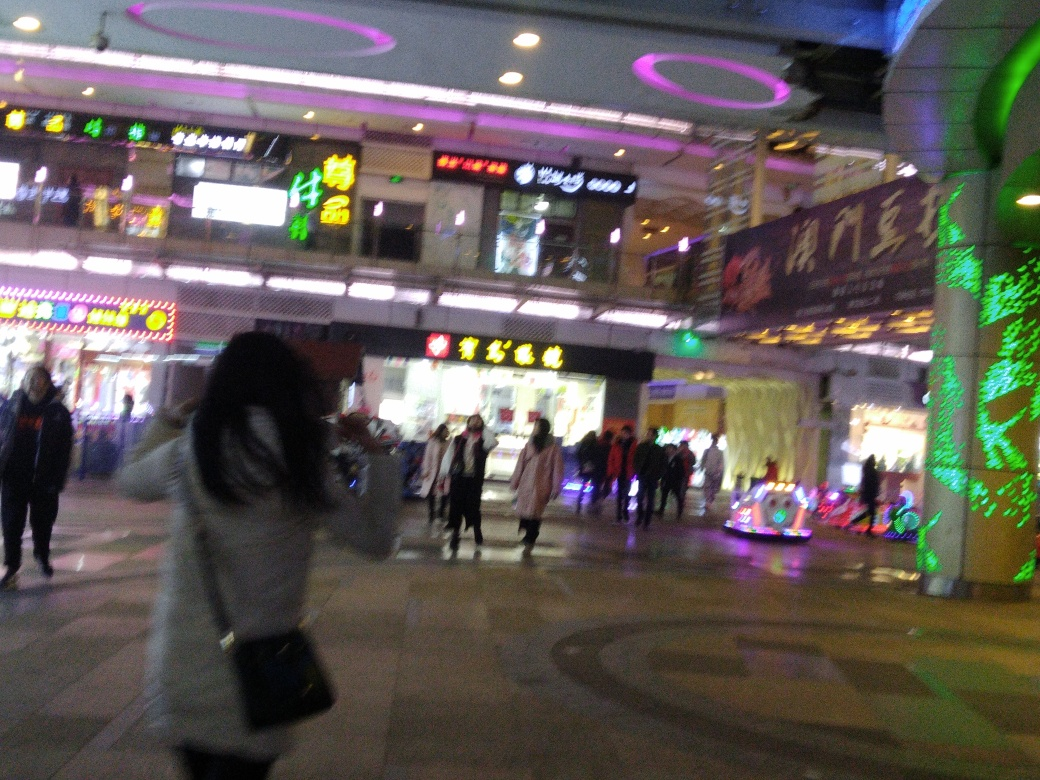Can you describe the atmosphere of the setting depicted in the image? The image exudes the vibrant energy of an evening in a bustling urban environment. Neon signs and illuminated decorations cast a colorful glow, which contrasts with the darkening sky, suggesting a lively commercial area active at night. The sense of movement, likely due to pedestrians going about their evenings, complements the dynamic feel of this urban scene. 